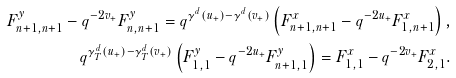Convert formula to latex. <formula><loc_0><loc_0><loc_500><loc_500>F ^ { y } _ { n + 1 , n + 1 } - q ^ { - 2 v _ { + } } F ^ { y } _ { n , n + 1 } = q ^ { \gamma ^ { d } ( u _ { + } ) - \gamma ^ { d } ( v _ { + } ) } \left ( F ^ { x } _ { n + 1 , n + 1 } - q ^ { - 2 u _ { + } } F ^ { x } _ { 1 , n + 1 } \right ) , \\ q ^ { \gamma _ { T } ^ { d } ( u _ { + } ) - \gamma _ { T } ^ { d } ( v _ { + } ) } \left ( F ^ { y } _ { 1 , 1 } - q ^ { - 2 u _ { + } } F ^ { y } _ { n + 1 , 1 } \right ) = F ^ { x } _ { 1 , 1 } - q ^ { - 2 v _ { + } } F ^ { x } _ { 2 , 1 } .</formula> 